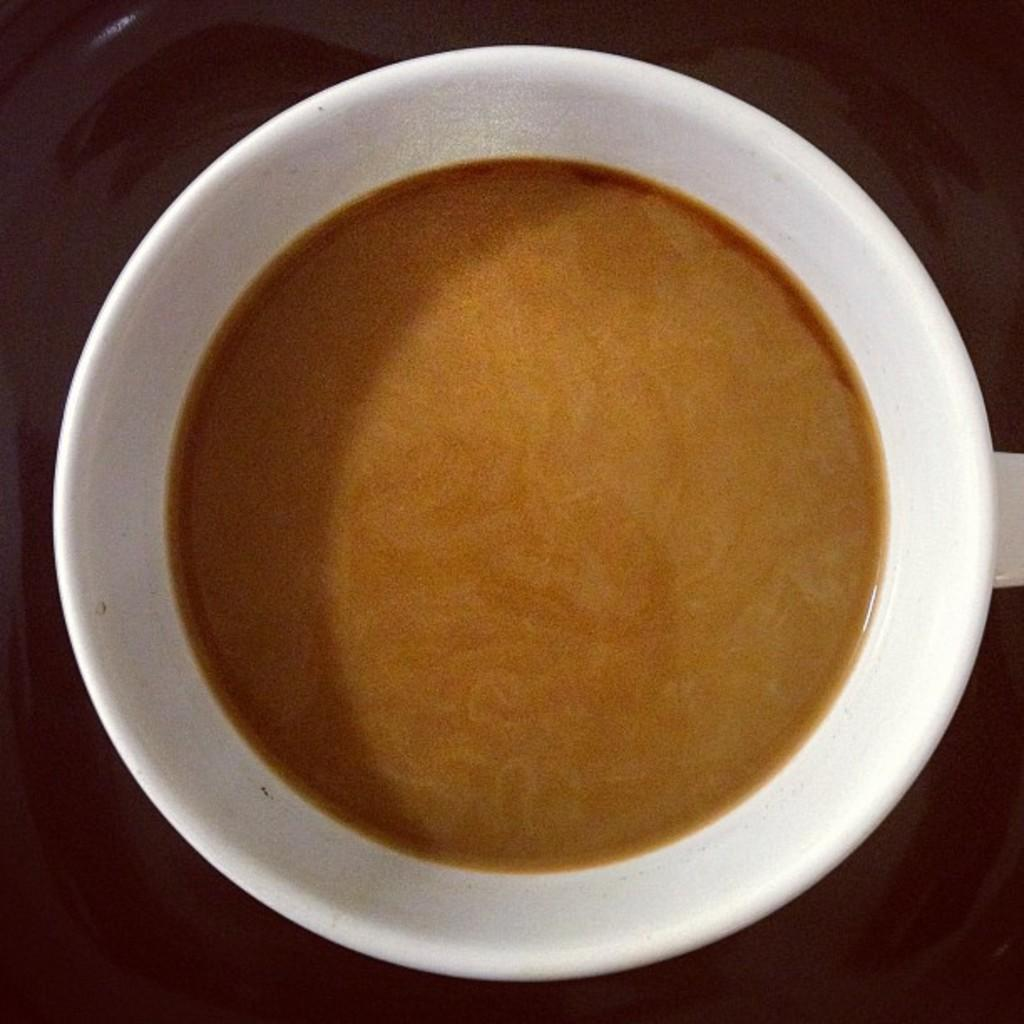What color is the cup that is visible in the image? The cup in the image is white. What is inside the cup? The cup contains tea. What type of wax can be seen melting in the cup? There is no wax present in the image; the cup contains tea. What is the profit margin of the tea in the cup? The image does not provide information about the profit margin of the tea in the cup. 